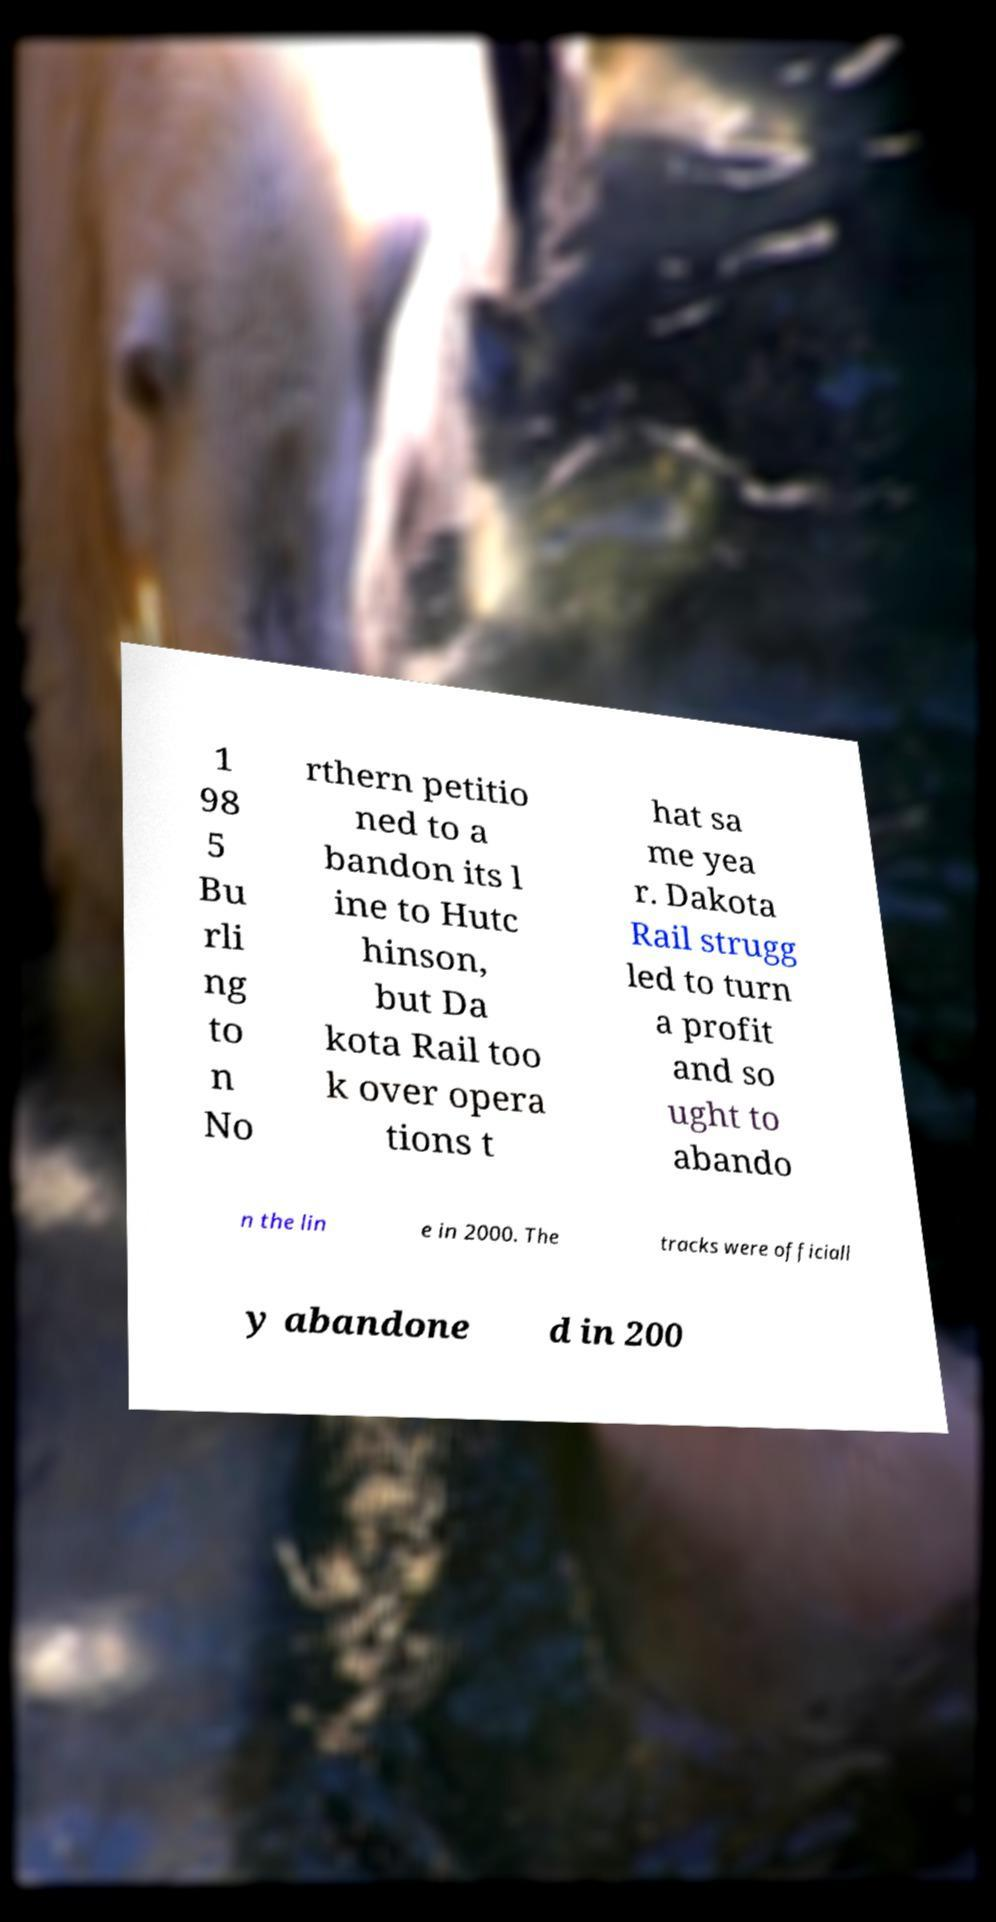I need the written content from this picture converted into text. Can you do that? 1 98 5 Bu rli ng to n No rthern petitio ned to a bandon its l ine to Hutc hinson, but Da kota Rail too k over opera tions t hat sa me yea r. Dakota Rail strugg led to turn a profit and so ught to abando n the lin e in 2000. The tracks were officiall y abandone d in 200 